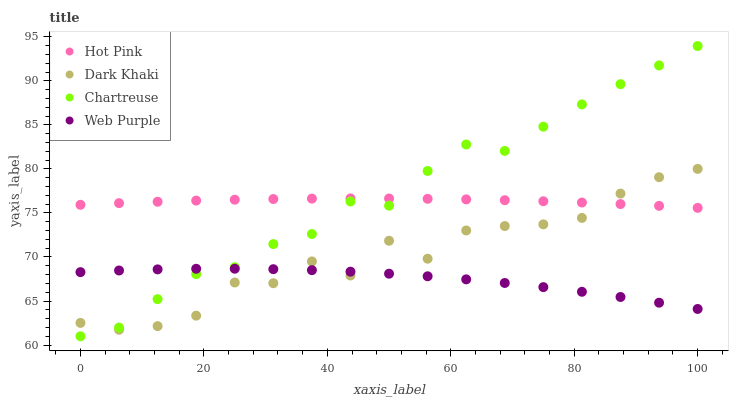Does Web Purple have the minimum area under the curve?
Answer yes or no. Yes. Does Chartreuse have the maximum area under the curve?
Answer yes or no. Yes. Does Hot Pink have the minimum area under the curve?
Answer yes or no. No. Does Hot Pink have the maximum area under the curve?
Answer yes or no. No. Is Hot Pink the smoothest?
Answer yes or no. Yes. Is Dark Khaki the roughest?
Answer yes or no. Yes. Is Chartreuse the smoothest?
Answer yes or no. No. Is Chartreuse the roughest?
Answer yes or no. No. Does Chartreuse have the lowest value?
Answer yes or no. Yes. Does Hot Pink have the lowest value?
Answer yes or no. No. Does Chartreuse have the highest value?
Answer yes or no. Yes. Does Hot Pink have the highest value?
Answer yes or no. No. Is Web Purple less than Hot Pink?
Answer yes or no. Yes. Is Hot Pink greater than Web Purple?
Answer yes or no. Yes. Does Web Purple intersect Dark Khaki?
Answer yes or no. Yes. Is Web Purple less than Dark Khaki?
Answer yes or no. No. Is Web Purple greater than Dark Khaki?
Answer yes or no. No. Does Web Purple intersect Hot Pink?
Answer yes or no. No. 